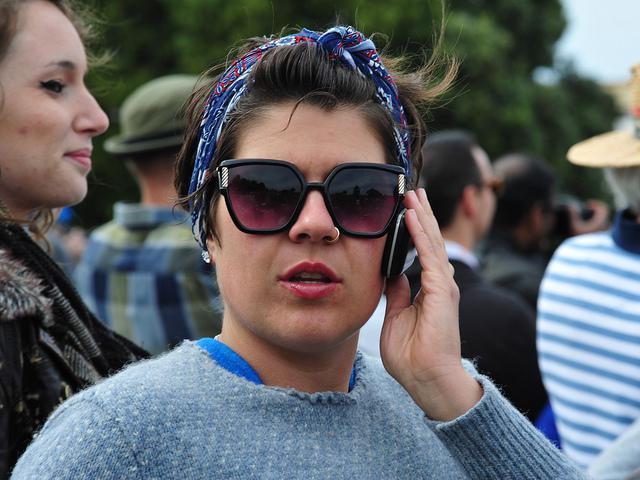What is the most likely purpose for the glasses on the girls face?
Select the accurate response from the four choices given to answer the question.
Options: Hide hangover, cool color, extra weight, blocking sun. Blocking sun. 